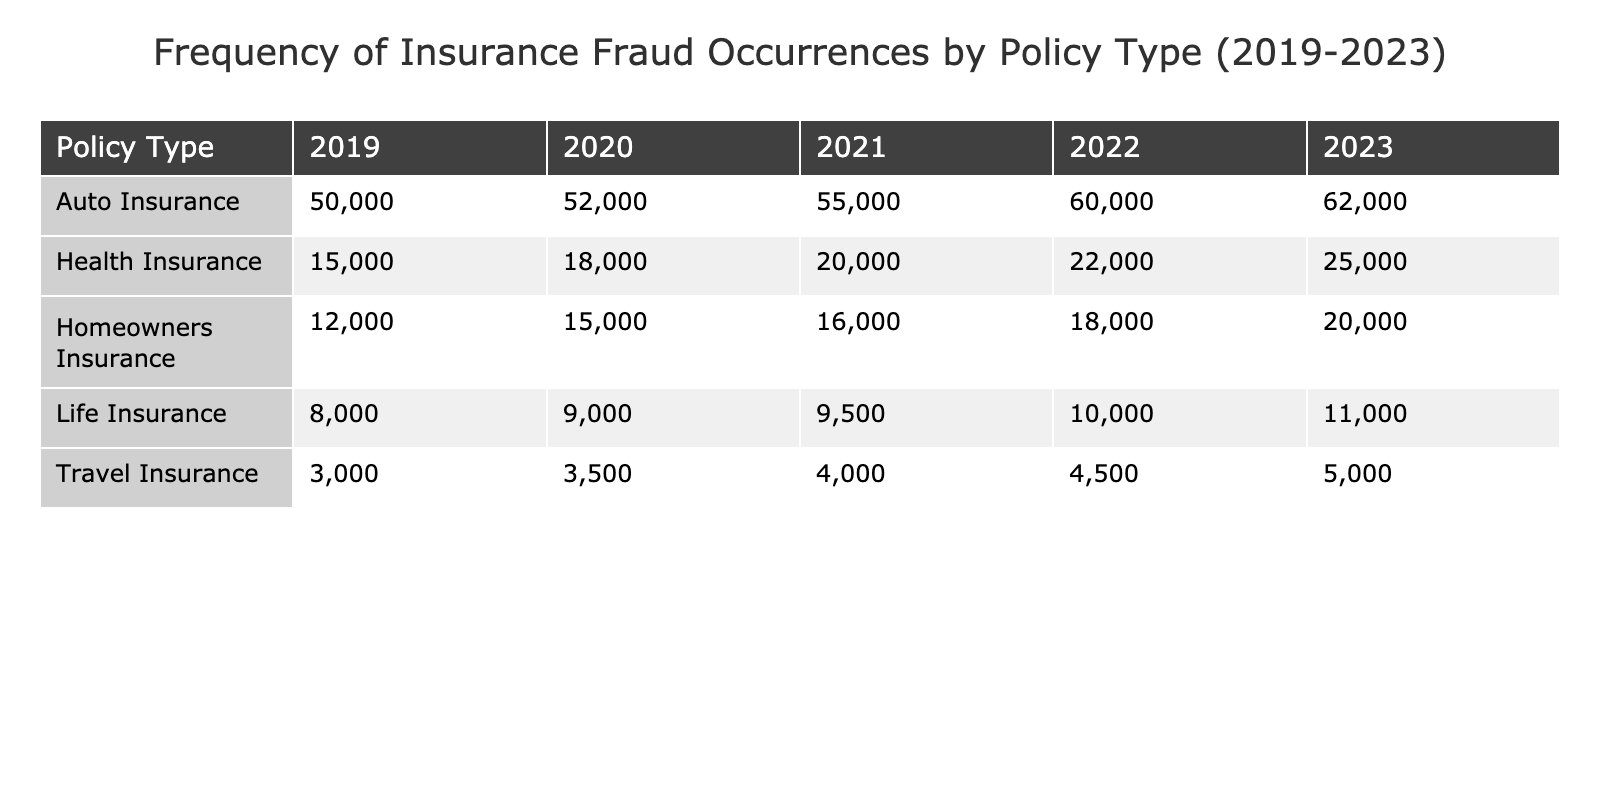What was the total number of insurance fraud occurrences for Health Insurance from 2019 to 2023? To find the total, sum the occurrences from each year: 15000 + 18000 + 20000 + 22000 + 25000 = 110000
Answer: 110000 Which type of insurance had the highest number of fraud occurrences in 2022? The table shows that Auto Insurance had 60000 occurrences in 2022, which is higher than all other types for that year.
Answer: Auto Insurance What is the percentage increase in fraud occurrences for Travel Insurance from 2019 to 2023? Calculate the occurrences for Travel Insurance in both years: 3000 in 2019 and 5000 in 2023. The increase is 5000 - 3000 = 2000. The percentage increase is (2000 / 3000) * 100 = 66.67%.
Answer: 66.67% Did Life Insurance have more than 10000 occurrences in 2022? The table shows that Life Insurance had 10000 occurrences in 2022, which means it did not exceed that number.
Answer: No What was the average number of insurance fraud occurrences across all policy types in 2021? First, sum the occurrences for all types in 2021: 20000 (Health) + 55000 (Auto) + 16000 (Homeowners) + 9500 (Life) + 4000 (Travel) = 110500. There are 5 types, so the average is 110500 / 5 = 22100.
Answer: 22100 Which year saw the lowest occurrence of fraud for Homeowners Insurance? Looking at the occurrences for Homeowners Insurance: 12000 (2019), 15000 (2020), 16000 (2021), 18000 (2022), 20000 (2023), 12000 in 2019 is the lowest.
Answer: 2019 What is the total number of fraud occurrences for Auto Insurance over the years? Sum the occurrences for Auto Insurance: 50000 + 52000 + 55000 + 60000 + 62000 = 279000
Answer: 279000 Was there a decline in fraud occurrences for any type of insurance from 2022 to 2023? Check the occurrences for each type in 2022 and 2023: Health (22000 to 25000), Auto (60000 to 62000), Homeowners (18000 to 20000), Life (10000 to 11000), Travel (4500 to 5000). All types increased, so there was no decline.
Answer: No What is the difference in occurrences between the highest and lowest types of insurance fraud in 2023? In 2023, Auto Insurance had 62000 occurrences (highest) and Travel Insurance had 5000 occurrences (lowest). The difference is 62000 - 5000 = 57000.
Answer: 57000 Which type of insurance had the most consistent yearly occurrences from 2019 to 2023? Analyze the yearly changes: Travel Insurance has increments of 500, while others have larger fluctuations. Therefore, Travel Insurance has the most consistent occurrence increases.
Answer: Travel Insurance 